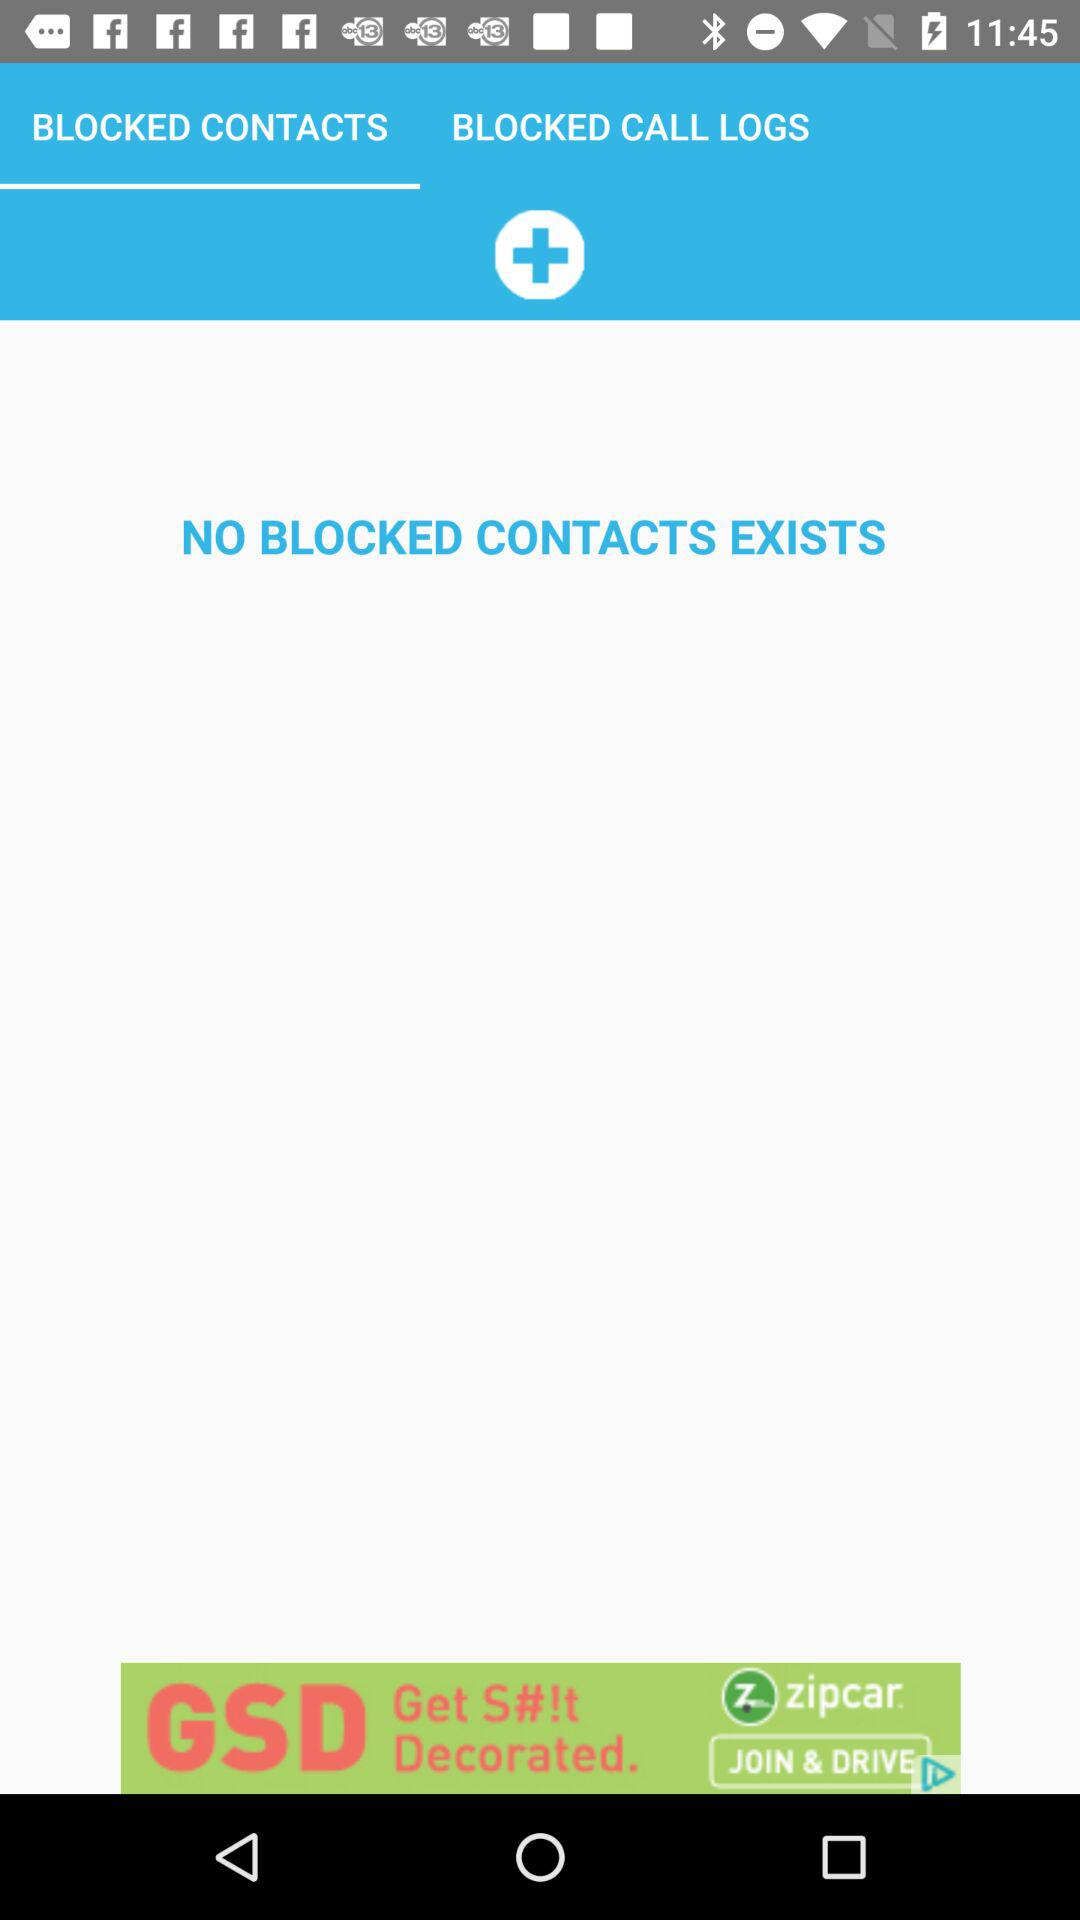How many blocked contacts are there? There are no blocked contacts. 